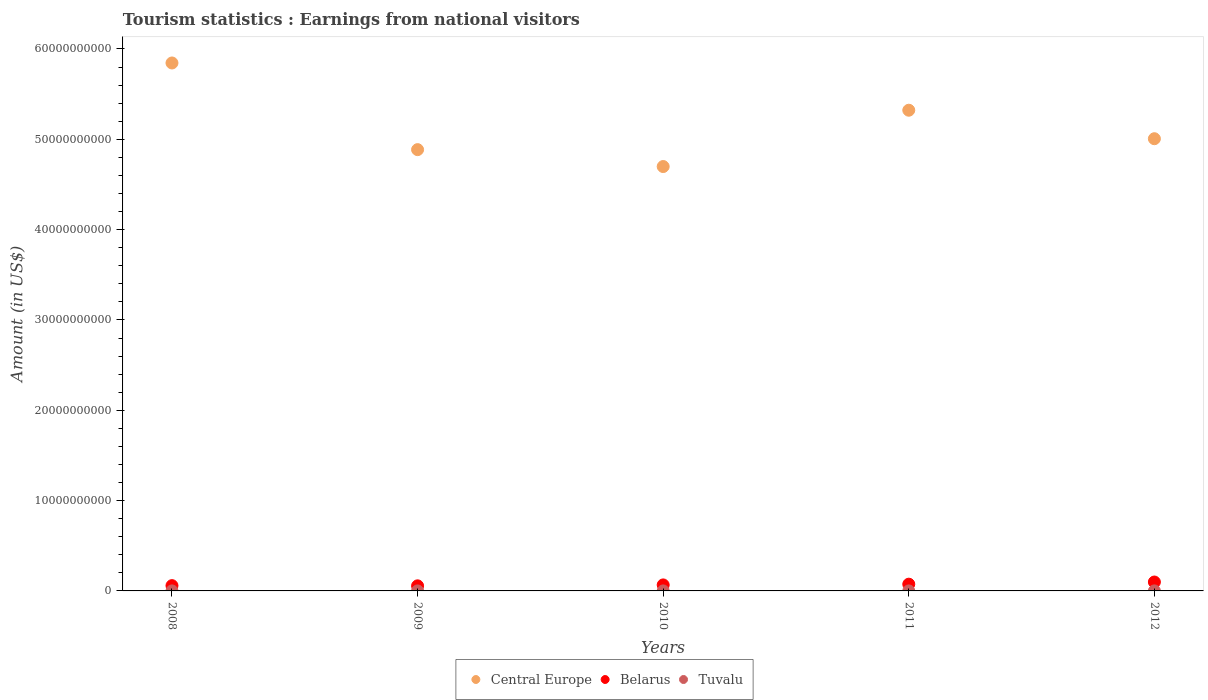How many different coloured dotlines are there?
Your answer should be compact. 3. What is the earnings from national visitors in Tuvalu in 2011?
Make the answer very short. 2.44e+06. Across all years, what is the maximum earnings from national visitors in Belarus?
Make the answer very short. 9.86e+08. Across all years, what is the minimum earnings from national visitors in Tuvalu?
Offer a terse response. 1.53e+06. In which year was the earnings from national visitors in Tuvalu minimum?
Make the answer very short. 2009. What is the total earnings from national visitors in Belarus in the graph?
Your answer should be compact. 3.55e+09. What is the difference between the earnings from national visitors in Tuvalu in 2008 and that in 2011?
Your response must be concise. -5.70e+05. What is the difference between the earnings from national visitors in Tuvalu in 2010 and the earnings from national visitors in Belarus in 2012?
Keep it short and to the point. -9.84e+08. What is the average earnings from national visitors in Tuvalu per year?
Give a very brief answer. 2.17e+06. In the year 2008, what is the difference between the earnings from national visitors in Belarus and earnings from national visitors in Central Europe?
Offer a terse response. -5.79e+1. What is the ratio of the earnings from national visitors in Central Europe in 2011 to that in 2012?
Your answer should be very brief. 1.06. Is the earnings from national visitors in Central Europe in 2010 less than that in 2012?
Make the answer very short. Yes. Is the difference between the earnings from national visitors in Belarus in 2011 and 2012 greater than the difference between the earnings from national visitors in Central Europe in 2011 and 2012?
Provide a short and direct response. No. What is the difference between the highest and the second highest earnings from national visitors in Central Europe?
Ensure brevity in your answer.  5.23e+09. What is the difference between the highest and the lowest earnings from national visitors in Central Europe?
Provide a short and direct response. 1.15e+1. Is it the case that in every year, the sum of the earnings from national visitors in Belarus and earnings from national visitors in Tuvalu  is greater than the earnings from national visitors in Central Europe?
Your response must be concise. No. Is the earnings from national visitors in Tuvalu strictly greater than the earnings from national visitors in Central Europe over the years?
Make the answer very short. No. How many dotlines are there?
Keep it short and to the point. 3. How many years are there in the graph?
Provide a short and direct response. 5. What is the difference between two consecutive major ticks on the Y-axis?
Ensure brevity in your answer.  1.00e+1. Are the values on the major ticks of Y-axis written in scientific E-notation?
Ensure brevity in your answer.  No. Does the graph contain any zero values?
Provide a succinct answer. No. How are the legend labels stacked?
Provide a succinct answer. Horizontal. What is the title of the graph?
Your answer should be compact. Tourism statistics : Earnings from national visitors. What is the label or title of the Y-axis?
Give a very brief answer. Amount (in US$). What is the Amount (in US$) in Central Europe in 2008?
Make the answer very short. 5.84e+1. What is the Amount (in US$) of Belarus in 2008?
Make the answer very short. 5.85e+08. What is the Amount (in US$) in Tuvalu in 2008?
Your answer should be compact. 1.87e+06. What is the Amount (in US$) in Central Europe in 2009?
Your answer should be very brief. 4.89e+1. What is the Amount (in US$) of Belarus in 2009?
Offer a terse response. 5.63e+08. What is the Amount (in US$) in Tuvalu in 2009?
Your answer should be compact. 1.53e+06. What is the Amount (in US$) in Central Europe in 2010?
Ensure brevity in your answer.  4.70e+1. What is the Amount (in US$) of Belarus in 2010?
Provide a short and direct response. 6.65e+08. What is the Amount (in US$) in Tuvalu in 2010?
Your response must be concise. 2.35e+06. What is the Amount (in US$) in Central Europe in 2011?
Your answer should be very brief. 5.32e+1. What is the Amount (in US$) in Belarus in 2011?
Offer a terse response. 7.47e+08. What is the Amount (in US$) in Tuvalu in 2011?
Provide a succinct answer. 2.44e+06. What is the Amount (in US$) of Central Europe in 2012?
Your answer should be compact. 5.01e+1. What is the Amount (in US$) in Belarus in 2012?
Give a very brief answer. 9.86e+08. What is the Amount (in US$) in Tuvalu in 2012?
Your response must be concise. 2.67e+06. Across all years, what is the maximum Amount (in US$) in Central Europe?
Offer a very short reply. 5.84e+1. Across all years, what is the maximum Amount (in US$) in Belarus?
Offer a terse response. 9.86e+08. Across all years, what is the maximum Amount (in US$) in Tuvalu?
Provide a short and direct response. 2.67e+06. Across all years, what is the minimum Amount (in US$) of Central Europe?
Make the answer very short. 4.70e+1. Across all years, what is the minimum Amount (in US$) in Belarus?
Keep it short and to the point. 5.63e+08. Across all years, what is the minimum Amount (in US$) of Tuvalu?
Your answer should be very brief. 1.53e+06. What is the total Amount (in US$) in Central Europe in the graph?
Your response must be concise. 2.58e+11. What is the total Amount (in US$) of Belarus in the graph?
Provide a succinct answer. 3.55e+09. What is the total Amount (in US$) in Tuvalu in the graph?
Offer a very short reply. 1.09e+07. What is the difference between the Amount (in US$) in Central Europe in 2008 and that in 2009?
Make the answer very short. 9.60e+09. What is the difference between the Amount (in US$) in Belarus in 2008 and that in 2009?
Your response must be concise. 2.20e+07. What is the difference between the Amount (in US$) of Central Europe in 2008 and that in 2010?
Make the answer very short. 1.15e+1. What is the difference between the Amount (in US$) in Belarus in 2008 and that in 2010?
Offer a very short reply. -8.00e+07. What is the difference between the Amount (in US$) in Tuvalu in 2008 and that in 2010?
Offer a terse response. -4.80e+05. What is the difference between the Amount (in US$) of Central Europe in 2008 and that in 2011?
Your answer should be very brief. 5.23e+09. What is the difference between the Amount (in US$) of Belarus in 2008 and that in 2011?
Offer a very short reply. -1.62e+08. What is the difference between the Amount (in US$) in Tuvalu in 2008 and that in 2011?
Your response must be concise. -5.70e+05. What is the difference between the Amount (in US$) of Central Europe in 2008 and that in 2012?
Provide a short and direct response. 8.39e+09. What is the difference between the Amount (in US$) of Belarus in 2008 and that in 2012?
Offer a terse response. -4.01e+08. What is the difference between the Amount (in US$) of Tuvalu in 2008 and that in 2012?
Your answer should be very brief. -8.00e+05. What is the difference between the Amount (in US$) in Central Europe in 2009 and that in 2010?
Keep it short and to the point. 1.87e+09. What is the difference between the Amount (in US$) in Belarus in 2009 and that in 2010?
Provide a short and direct response. -1.02e+08. What is the difference between the Amount (in US$) in Tuvalu in 2009 and that in 2010?
Give a very brief answer. -8.20e+05. What is the difference between the Amount (in US$) in Central Europe in 2009 and that in 2011?
Your response must be concise. -4.36e+09. What is the difference between the Amount (in US$) of Belarus in 2009 and that in 2011?
Keep it short and to the point. -1.84e+08. What is the difference between the Amount (in US$) in Tuvalu in 2009 and that in 2011?
Offer a very short reply. -9.10e+05. What is the difference between the Amount (in US$) of Central Europe in 2009 and that in 2012?
Your response must be concise. -1.21e+09. What is the difference between the Amount (in US$) in Belarus in 2009 and that in 2012?
Provide a short and direct response. -4.23e+08. What is the difference between the Amount (in US$) of Tuvalu in 2009 and that in 2012?
Offer a terse response. -1.14e+06. What is the difference between the Amount (in US$) in Central Europe in 2010 and that in 2011?
Your response must be concise. -6.24e+09. What is the difference between the Amount (in US$) in Belarus in 2010 and that in 2011?
Your response must be concise. -8.20e+07. What is the difference between the Amount (in US$) in Tuvalu in 2010 and that in 2011?
Keep it short and to the point. -9.00e+04. What is the difference between the Amount (in US$) of Central Europe in 2010 and that in 2012?
Offer a terse response. -3.08e+09. What is the difference between the Amount (in US$) of Belarus in 2010 and that in 2012?
Give a very brief answer. -3.21e+08. What is the difference between the Amount (in US$) of Tuvalu in 2010 and that in 2012?
Your answer should be compact. -3.20e+05. What is the difference between the Amount (in US$) in Central Europe in 2011 and that in 2012?
Give a very brief answer. 3.16e+09. What is the difference between the Amount (in US$) in Belarus in 2011 and that in 2012?
Your answer should be very brief. -2.39e+08. What is the difference between the Amount (in US$) in Central Europe in 2008 and the Amount (in US$) in Belarus in 2009?
Offer a terse response. 5.79e+1. What is the difference between the Amount (in US$) in Central Europe in 2008 and the Amount (in US$) in Tuvalu in 2009?
Your response must be concise. 5.84e+1. What is the difference between the Amount (in US$) of Belarus in 2008 and the Amount (in US$) of Tuvalu in 2009?
Keep it short and to the point. 5.83e+08. What is the difference between the Amount (in US$) of Central Europe in 2008 and the Amount (in US$) of Belarus in 2010?
Offer a terse response. 5.78e+1. What is the difference between the Amount (in US$) of Central Europe in 2008 and the Amount (in US$) of Tuvalu in 2010?
Offer a very short reply. 5.84e+1. What is the difference between the Amount (in US$) of Belarus in 2008 and the Amount (in US$) of Tuvalu in 2010?
Make the answer very short. 5.83e+08. What is the difference between the Amount (in US$) of Central Europe in 2008 and the Amount (in US$) of Belarus in 2011?
Offer a very short reply. 5.77e+1. What is the difference between the Amount (in US$) of Central Europe in 2008 and the Amount (in US$) of Tuvalu in 2011?
Your answer should be compact. 5.84e+1. What is the difference between the Amount (in US$) of Belarus in 2008 and the Amount (in US$) of Tuvalu in 2011?
Your answer should be very brief. 5.83e+08. What is the difference between the Amount (in US$) in Central Europe in 2008 and the Amount (in US$) in Belarus in 2012?
Provide a succinct answer. 5.75e+1. What is the difference between the Amount (in US$) in Central Europe in 2008 and the Amount (in US$) in Tuvalu in 2012?
Your answer should be compact. 5.84e+1. What is the difference between the Amount (in US$) of Belarus in 2008 and the Amount (in US$) of Tuvalu in 2012?
Keep it short and to the point. 5.82e+08. What is the difference between the Amount (in US$) of Central Europe in 2009 and the Amount (in US$) of Belarus in 2010?
Give a very brief answer. 4.82e+1. What is the difference between the Amount (in US$) in Central Europe in 2009 and the Amount (in US$) in Tuvalu in 2010?
Ensure brevity in your answer.  4.89e+1. What is the difference between the Amount (in US$) of Belarus in 2009 and the Amount (in US$) of Tuvalu in 2010?
Give a very brief answer. 5.61e+08. What is the difference between the Amount (in US$) in Central Europe in 2009 and the Amount (in US$) in Belarus in 2011?
Give a very brief answer. 4.81e+1. What is the difference between the Amount (in US$) in Central Europe in 2009 and the Amount (in US$) in Tuvalu in 2011?
Keep it short and to the point. 4.89e+1. What is the difference between the Amount (in US$) of Belarus in 2009 and the Amount (in US$) of Tuvalu in 2011?
Keep it short and to the point. 5.61e+08. What is the difference between the Amount (in US$) of Central Europe in 2009 and the Amount (in US$) of Belarus in 2012?
Offer a very short reply. 4.79e+1. What is the difference between the Amount (in US$) in Central Europe in 2009 and the Amount (in US$) in Tuvalu in 2012?
Offer a terse response. 4.89e+1. What is the difference between the Amount (in US$) in Belarus in 2009 and the Amount (in US$) in Tuvalu in 2012?
Offer a very short reply. 5.60e+08. What is the difference between the Amount (in US$) of Central Europe in 2010 and the Amount (in US$) of Belarus in 2011?
Your answer should be compact. 4.62e+1. What is the difference between the Amount (in US$) in Central Europe in 2010 and the Amount (in US$) in Tuvalu in 2011?
Make the answer very short. 4.70e+1. What is the difference between the Amount (in US$) in Belarus in 2010 and the Amount (in US$) in Tuvalu in 2011?
Make the answer very short. 6.63e+08. What is the difference between the Amount (in US$) of Central Europe in 2010 and the Amount (in US$) of Belarus in 2012?
Provide a short and direct response. 4.60e+1. What is the difference between the Amount (in US$) in Central Europe in 2010 and the Amount (in US$) in Tuvalu in 2012?
Offer a terse response. 4.70e+1. What is the difference between the Amount (in US$) in Belarus in 2010 and the Amount (in US$) in Tuvalu in 2012?
Offer a very short reply. 6.62e+08. What is the difference between the Amount (in US$) in Central Europe in 2011 and the Amount (in US$) in Belarus in 2012?
Keep it short and to the point. 5.22e+1. What is the difference between the Amount (in US$) of Central Europe in 2011 and the Amount (in US$) of Tuvalu in 2012?
Your response must be concise. 5.32e+1. What is the difference between the Amount (in US$) in Belarus in 2011 and the Amount (in US$) in Tuvalu in 2012?
Your response must be concise. 7.44e+08. What is the average Amount (in US$) of Central Europe per year?
Provide a succinct answer. 5.15e+1. What is the average Amount (in US$) in Belarus per year?
Provide a short and direct response. 7.09e+08. What is the average Amount (in US$) of Tuvalu per year?
Your response must be concise. 2.17e+06. In the year 2008, what is the difference between the Amount (in US$) of Central Europe and Amount (in US$) of Belarus?
Your answer should be compact. 5.79e+1. In the year 2008, what is the difference between the Amount (in US$) of Central Europe and Amount (in US$) of Tuvalu?
Your answer should be very brief. 5.84e+1. In the year 2008, what is the difference between the Amount (in US$) of Belarus and Amount (in US$) of Tuvalu?
Your answer should be compact. 5.83e+08. In the year 2009, what is the difference between the Amount (in US$) in Central Europe and Amount (in US$) in Belarus?
Provide a short and direct response. 4.83e+1. In the year 2009, what is the difference between the Amount (in US$) in Central Europe and Amount (in US$) in Tuvalu?
Provide a short and direct response. 4.89e+1. In the year 2009, what is the difference between the Amount (in US$) of Belarus and Amount (in US$) of Tuvalu?
Offer a terse response. 5.61e+08. In the year 2010, what is the difference between the Amount (in US$) of Central Europe and Amount (in US$) of Belarus?
Make the answer very short. 4.63e+1. In the year 2010, what is the difference between the Amount (in US$) of Central Europe and Amount (in US$) of Tuvalu?
Offer a very short reply. 4.70e+1. In the year 2010, what is the difference between the Amount (in US$) in Belarus and Amount (in US$) in Tuvalu?
Ensure brevity in your answer.  6.63e+08. In the year 2011, what is the difference between the Amount (in US$) in Central Europe and Amount (in US$) in Belarus?
Your response must be concise. 5.25e+1. In the year 2011, what is the difference between the Amount (in US$) in Central Europe and Amount (in US$) in Tuvalu?
Provide a succinct answer. 5.32e+1. In the year 2011, what is the difference between the Amount (in US$) of Belarus and Amount (in US$) of Tuvalu?
Your answer should be very brief. 7.45e+08. In the year 2012, what is the difference between the Amount (in US$) of Central Europe and Amount (in US$) of Belarus?
Offer a very short reply. 4.91e+1. In the year 2012, what is the difference between the Amount (in US$) of Central Europe and Amount (in US$) of Tuvalu?
Keep it short and to the point. 5.01e+1. In the year 2012, what is the difference between the Amount (in US$) of Belarus and Amount (in US$) of Tuvalu?
Provide a short and direct response. 9.83e+08. What is the ratio of the Amount (in US$) of Central Europe in 2008 to that in 2009?
Your answer should be very brief. 1.2. What is the ratio of the Amount (in US$) in Belarus in 2008 to that in 2009?
Your answer should be very brief. 1.04. What is the ratio of the Amount (in US$) of Tuvalu in 2008 to that in 2009?
Ensure brevity in your answer.  1.22. What is the ratio of the Amount (in US$) in Central Europe in 2008 to that in 2010?
Keep it short and to the point. 1.24. What is the ratio of the Amount (in US$) in Belarus in 2008 to that in 2010?
Provide a succinct answer. 0.88. What is the ratio of the Amount (in US$) of Tuvalu in 2008 to that in 2010?
Your answer should be compact. 0.8. What is the ratio of the Amount (in US$) of Central Europe in 2008 to that in 2011?
Provide a succinct answer. 1.1. What is the ratio of the Amount (in US$) of Belarus in 2008 to that in 2011?
Your answer should be very brief. 0.78. What is the ratio of the Amount (in US$) in Tuvalu in 2008 to that in 2011?
Provide a short and direct response. 0.77. What is the ratio of the Amount (in US$) in Central Europe in 2008 to that in 2012?
Your response must be concise. 1.17. What is the ratio of the Amount (in US$) in Belarus in 2008 to that in 2012?
Ensure brevity in your answer.  0.59. What is the ratio of the Amount (in US$) of Tuvalu in 2008 to that in 2012?
Offer a terse response. 0.7. What is the ratio of the Amount (in US$) in Central Europe in 2009 to that in 2010?
Provide a succinct answer. 1.04. What is the ratio of the Amount (in US$) in Belarus in 2009 to that in 2010?
Make the answer very short. 0.85. What is the ratio of the Amount (in US$) in Tuvalu in 2009 to that in 2010?
Offer a terse response. 0.65. What is the ratio of the Amount (in US$) in Central Europe in 2009 to that in 2011?
Ensure brevity in your answer.  0.92. What is the ratio of the Amount (in US$) of Belarus in 2009 to that in 2011?
Your response must be concise. 0.75. What is the ratio of the Amount (in US$) of Tuvalu in 2009 to that in 2011?
Your answer should be very brief. 0.63. What is the ratio of the Amount (in US$) in Central Europe in 2009 to that in 2012?
Your answer should be very brief. 0.98. What is the ratio of the Amount (in US$) in Belarus in 2009 to that in 2012?
Provide a succinct answer. 0.57. What is the ratio of the Amount (in US$) in Tuvalu in 2009 to that in 2012?
Ensure brevity in your answer.  0.57. What is the ratio of the Amount (in US$) of Central Europe in 2010 to that in 2011?
Offer a very short reply. 0.88. What is the ratio of the Amount (in US$) in Belarus in 2010 to that in 2011?
Offer a terse response. 0.89. What is the ratio of the Amount (in US$) in Tuvalu in 2010 to that in 2011?
Provide a short and direct response. 0.96. What is the ratio of the Amount (in US$) in Central Europe in 2010 to that in 2012?
Give a very brief answer. 0.94. What is the ratio of the Amount (in US$) of Belarus in 2010 to that in 2012?
Offer a terse response. 0.67. What is the ratio of the Amount (in US$) of Tuvalu in 2010 to that in 2012?
Keep it short and to the point. 0.88. What is the ratio of the Amount (in US$) of Central Europe in 2011 to that in 2012?
Keep it short and to the point. 1.06. What is the ratio of the Amount (in US$) of Belarus in 2011 to that in 2012?
Your answer should be very brief. 0.76. What is the ratio of the Amount (in US$) in Tuvalu in 2011 to that in 2012?
Provide a succinct answer. 0.91. What is the difference between the highest and the second highest Amount (in US$) of Central Europe?
Provide a short and direct response. 5.23e+09. What is the difference between the highest and the second highest Amount (in US$) in Belarus?
Provide a short and direct response. 2.39e+08. What is the difference between the highest and the second highest Amount (in US$) of Tuvalu?
Your answer should be compact. 2.30e+05. What is the difference between the highest and the lowest Amount (in US$) of Central Europe?
Ensure brevity in your answer.  1.15e+1. What is the difference between the highest and the lowest Amount (in US$) in Belarus?
Give a very brief answer. 4.23e+08. What is the difference between the highest and the lowest Amount (in US$) of Tuvalu?
Provide a succinct answer. 1.14e+06. 